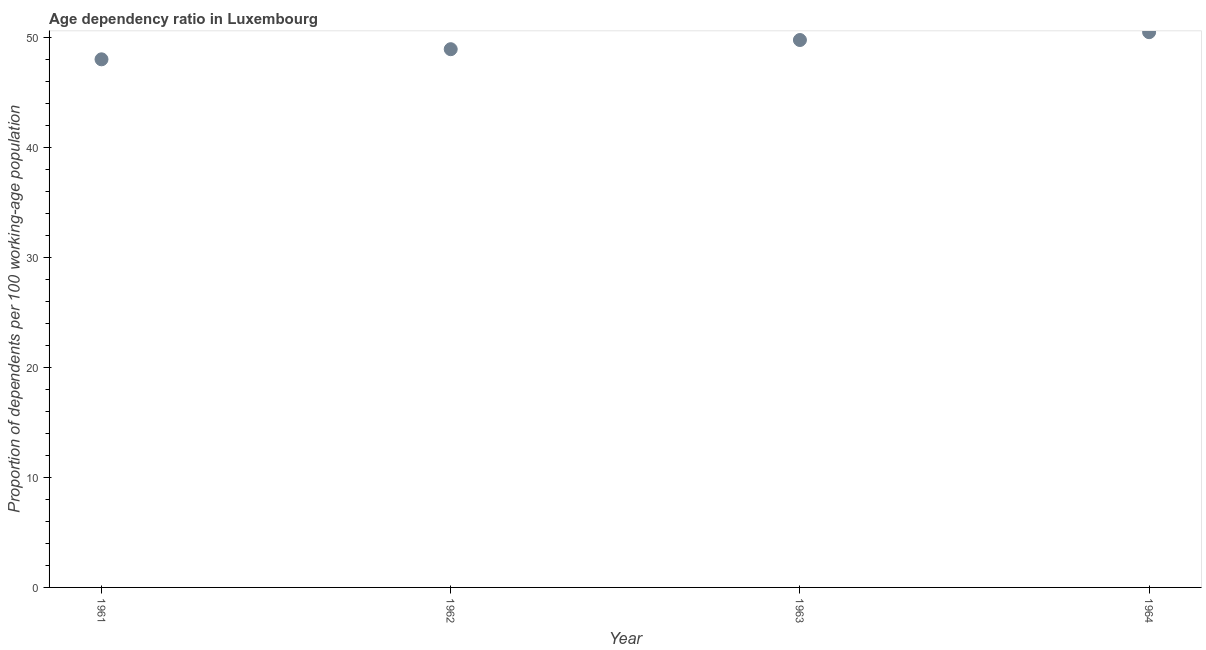What is the age dependency ratio in 1963?
Keep it short and to the point. 49.81. Across all years, what is the maximum age dependency ratio?
Give a very brief answer. 50.52. Across all years, what is the minimum age dependency ratio?
Offer a very short reply. 48.05. In which year was the age dependency ratio maximum?
Offer a terse response. 1964. In which year was the age dependency ratio minimum?
Your answer should be compact. 1961. What is the sum of the age dependency ratio?
Ensure brevity in your answer.  197.35. What is the difference between the age dependency ratio in 1962 and 1964?
Keep it short and to the point. -1.55. What is the average age dependency ratio per year?
Offer a terse response. 49.34. What is the median age dependency ratio?
Make the answer very short. 49.39. In how many years, is the age dependency ratio greater than 16 ?
Ensure brevity in your answer.  4. Do a majority of the years between 1961 and 1964 (inclusive) have age dependency ratio greater than 44 ?
Give a very brief answer. Yes. What is the ratio of the age dependency ratio in 1961 to that in 1962?
Give a very brief answer. 0.98. Is the difference between the age dependency ratio in 1962 and 1963 greater than the difference between any two years?
Offer a very short reply. No. What is the difference between the highest and the second highest age dependency ratio?
Provide a short and direct response. 0.71. Is the sum of the age dependency ratio in 1963 and 1964 greater than the maximum age dependency ratio across all years?
Make the answer very short. Yes. What is the difference between the highest and the lowest age dependency ratio?
Give a very brief answer. 2.47. In how many years, is the age dependency ratio greater than the average age dependency ratio taken over all years?
Provide a short and direct response. 2. How many years are there in the graph?
Your response must be concise. 4. What is the difference between two consecutive major ticks on the Y-axis?
Keep it short and to the point. 10. Are the values on the major ticks of Y-axis written in scientific E-notation?
Your answer should be compact. No. What is the title of the graph?
Ensure brevity in your answer.  Age dependency ratio in Luxembourg. What is the label or title of the X-axis?
Provide a short and direct response. Year. What is the label or title of the Y-axis?
Your answer should be compact. Proportion of dependents per 100 working-age population. What is the Proportion of dependents per 100 working-age population in 1961?
Ensure brevity in your answer.  48.05. What is the Proportion of dependents per 100 working-age population in 1962?
Give a very brief answer. 48.97. What is the Proportion of dependents per 100 working-age population in 1963?
Make the answer very short. 49.81. What is the Proportion of dependents per 100 working-age population in 1964?
Keep it short and to the point. 50.52. What is the difference between the Proportion of dependents per 100 working-age population in 1961 and 1962?
Keep it short and to the point. -0.92. What is the difference between the Proportion of dependents per 100 working-age population in 1961 and 1963?
Give a very brief answer. -1.76. What is the difference between the Proportion of dependents per 100 working-age population in 1961 and 1964?
Offer a terse response. -2.47. What is the difference between the Proportion of dependents per 100 working-age population in 1962 and 1963?
Offer a very short reply. -0.84. What is the difference between the Proportion of dependents per 100 working-age population in 1962 and 1964?
Make the answer very short. -1.55. What is the difference between the Proportion of dependents per 100 working-age population in 1963 and 1964?
Your answer should be very brief. -0.71. What is the ratio of the Proportion of dependents per 100 working-age population in 1961 to that in 1964?
Your answer should be very brief. 0.95. 